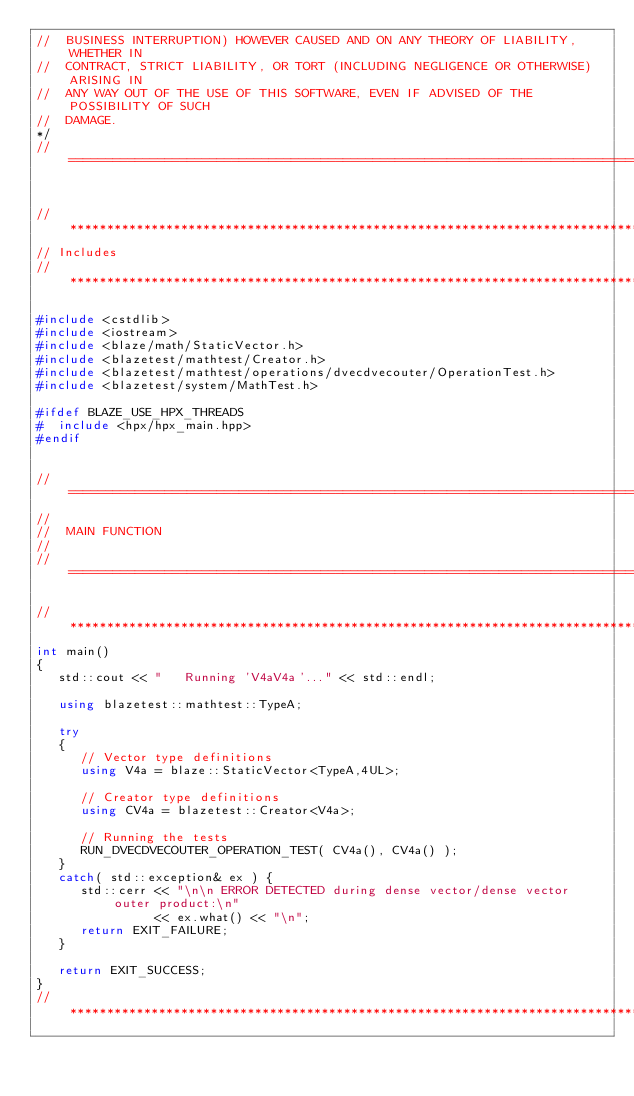Convert code to text. <code><loc_0><loc_0><loc_500><loc_500><_C++_>//  BUSINESS INTERRUPTION) HOWEVER CAUSED AND ON ANY THEORY OF LIABILITY, WHETHER IN
//  CONTRACT, STRICT LIABILITY, OR TORT (INCLUDING NEGLIGENCE OR OTHERWISE) ARISING IN
//  ANY WAY OUT OF THE USE OF THIS SOFTWARE, EVEN IF ADVISED OF THE POSSIBILITY OF SUCH
//  DAMAGE.
*/
//=================================================================================================


//*************************************************************************************************
// Includes
//*************************************************************************************************

#include <cstdlib>
#include <iostream>
#include <blaze/math/StaticVector.h>
#include <blazetest/mathtest/Creator.h>
#include <blazetest/mathtest/operations/dvecdvecouter/OperationTest.h>
#include <blazetest/system/MathTest.h>

#ifdef BLAZE_USE_HPX_THREADS
#  include <hpx/hpx_main.hpp>
#endif


//=================================================================================================
//
//  MAIN FUNCTION
//
//=================================================================================================

//*************************************************************************************************
int main()
{
   std::cout << "   Running 'V4aV4a'..." << std::endl;

   using blazetest::mathtest::TypeA;

   try
   {
      // Vector type definitions
      using V4a = blaze::StaticVector<TypeA,4UL>;

      // Creator type definitions
      using CV4a = blazetest::Creator<V4a>;

      // Running the tests
      RUN_DVECDVECOUTER_OPERATION_TEST( CV4a(), CV4a() );
   }
   catch( std::exception& ex ) {
      std::cerr << "\n\n ERROR DETECTED during dense vector/dense vector outer product:\n"
                << ex.what() << "\n";
      return EXIT_FAILURE;
   }

   return EXIT_SUCCESS;
}
//*************************************************************************************************
</code> 